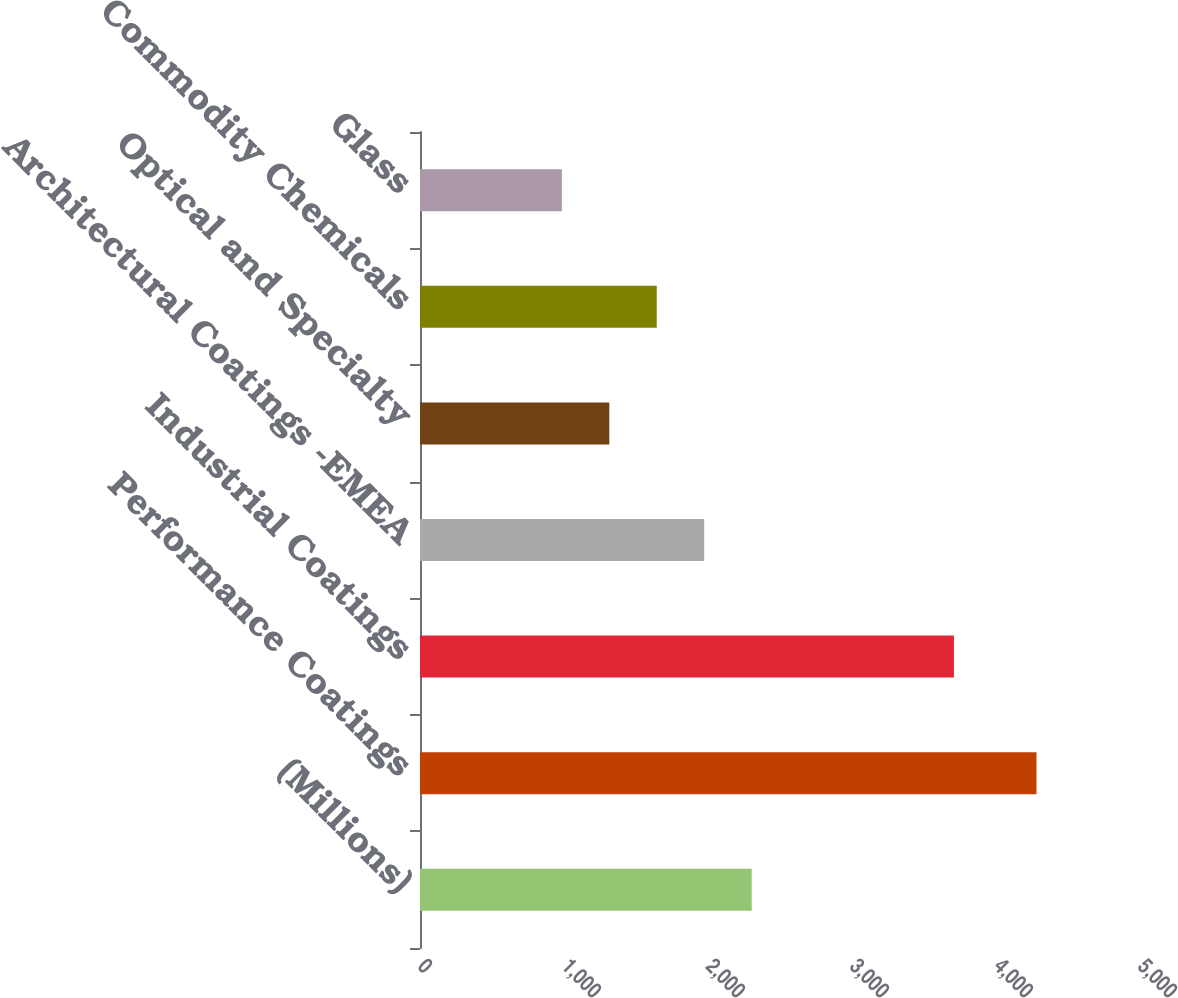Convert chart. <chart><loc_0><loc_0><loc_500><loc_500><bar_chart><fcel>(Millions)<fcel>Performance Coatings<fcel>Industrial Coatings<fcel>Architectural Coatings -EMEA<fcel>Optical and Specialty<fcel>Commodity Chemicals<fcel>Glass<nl><fcel>2303.4<fcel>4281<fcel>3708<fcel>1973.8<fcel>1314.6<fcel>1644.2<fcel>985<nl></chart> 